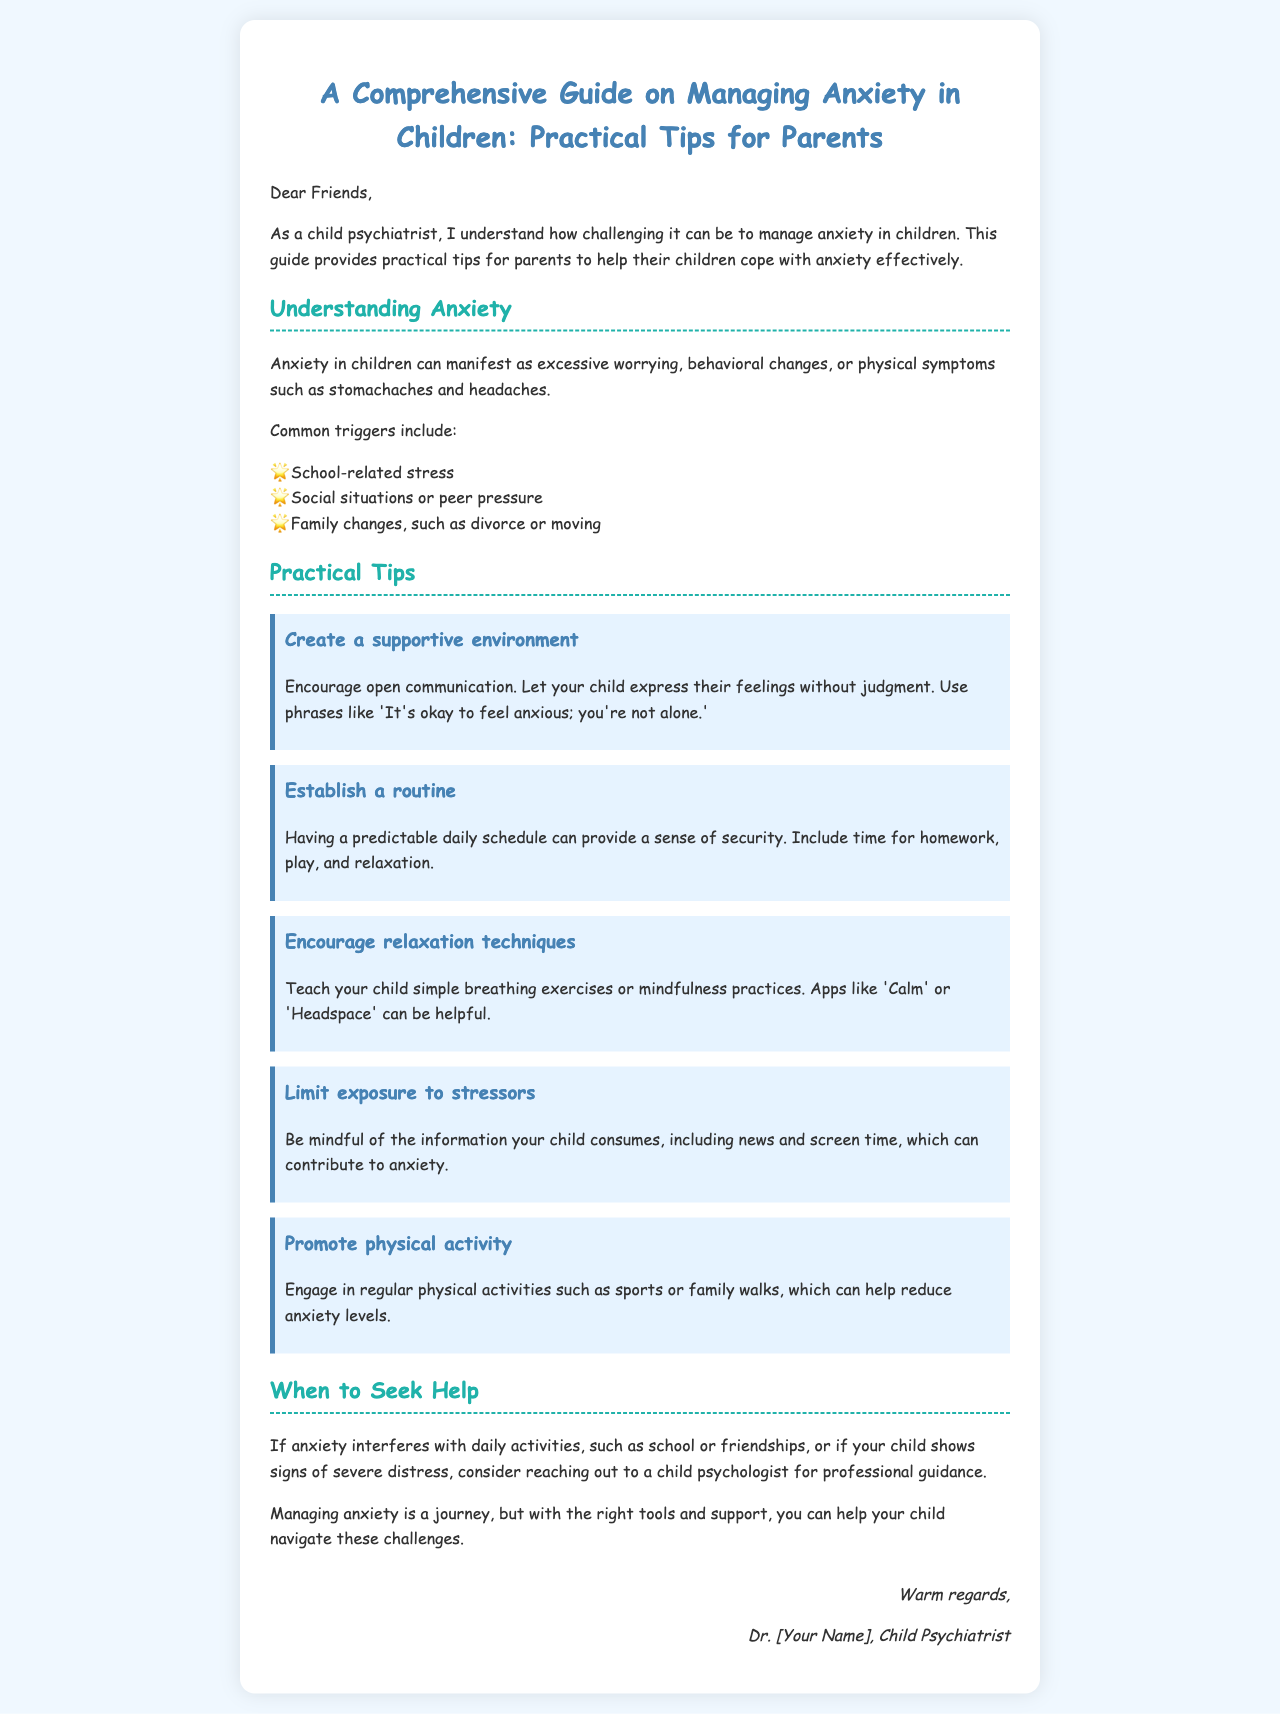What are common triggers for anxiety in children? The document lists common triggers that contribute to anxiety in children, including school-related stress, social situations, and family changes.
Answer: School-related stress, social situations, family changes Who is the guide intended for? The introduction of the document mentions that the guide is aimed at parents seeking to help their children cope with anxiety.
Answer: Parents What is one way to create a supportive environment? The document suggests encouraging open communication to let children express their feelings without judgment.
Answer: Encourage open communication What type of professional should parents consider consulting if anxiety interferes with daily activities? The document recommends reaching out to a child psychologist for professional guidance in cases of severe distress or significant interference in daily activities.
Answer: Child psychologist What is a relaxation technique mentioned in the guide? The document highlights breathing exercises and mindfulness practices as methods to help children relax.
Answer: Breathing exercises How many practical tips are provided in the document? The section on practical tips includes five key suggestions for parents to help manage their child's anxiety.
Answer: Five What color is used for the headings in the document? The headers in the document, like H1 and H2, are highlighted in specific colors to enhance visibility, particularly emphasizing the use of a shade of blue.
Answer: Blue What should parents do to limit exposure to stressors? The document advises being mindful of the information that children consume, as it can contribute to anxiety.
Answer: Be mindful of information consumed 